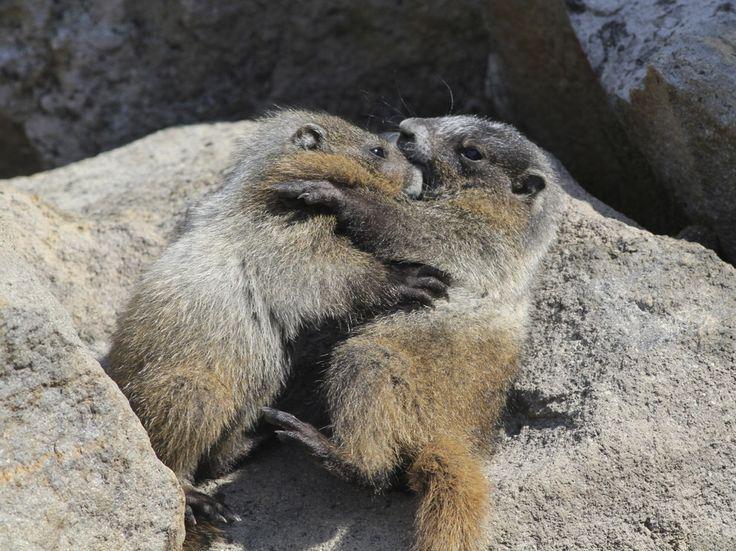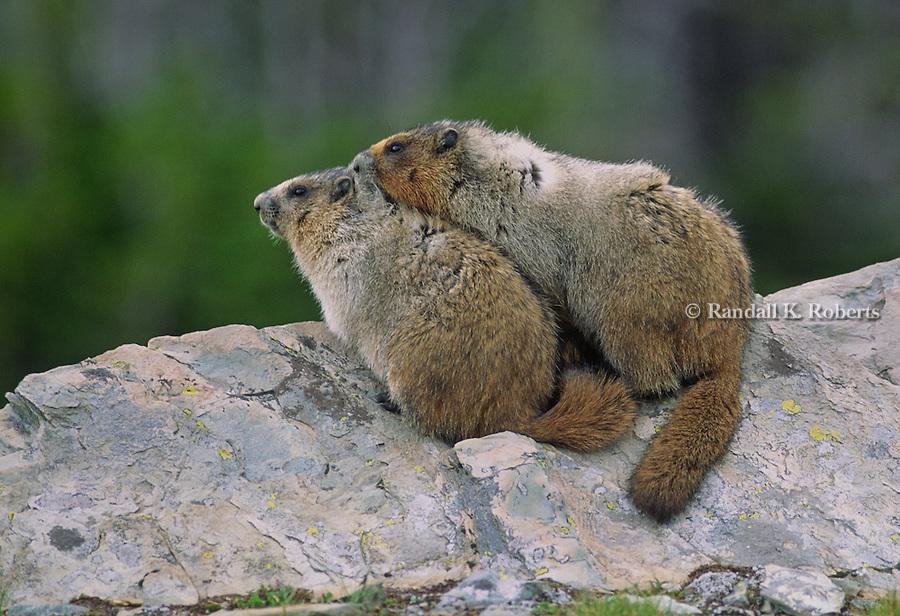The first image is the image on the left, the second image is the image on the right. Given the left and right images, does the statement "Each image contains just one marmot, and marmots on the right and left have similar style poses with some paws visible." hold true? Answer yes or no. No. The first image is the image on the left, the second image is the image on the right. For the images displayed, is the sentence "At least two animals are on a rocky surface." factually correct? Answer yes or no. Yes. 